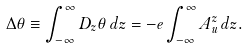Convert formula to latex. <formula><loc_0><loc_0><loc_500><loc_500>\Delta \theta \equiv \int _ { - \infty } ^ { \infty } D _ { z } \theta \, d z = - e \int _ { - \infty } ^ { \infty } A _ { u } ^ { z } \, d z .</formula> 